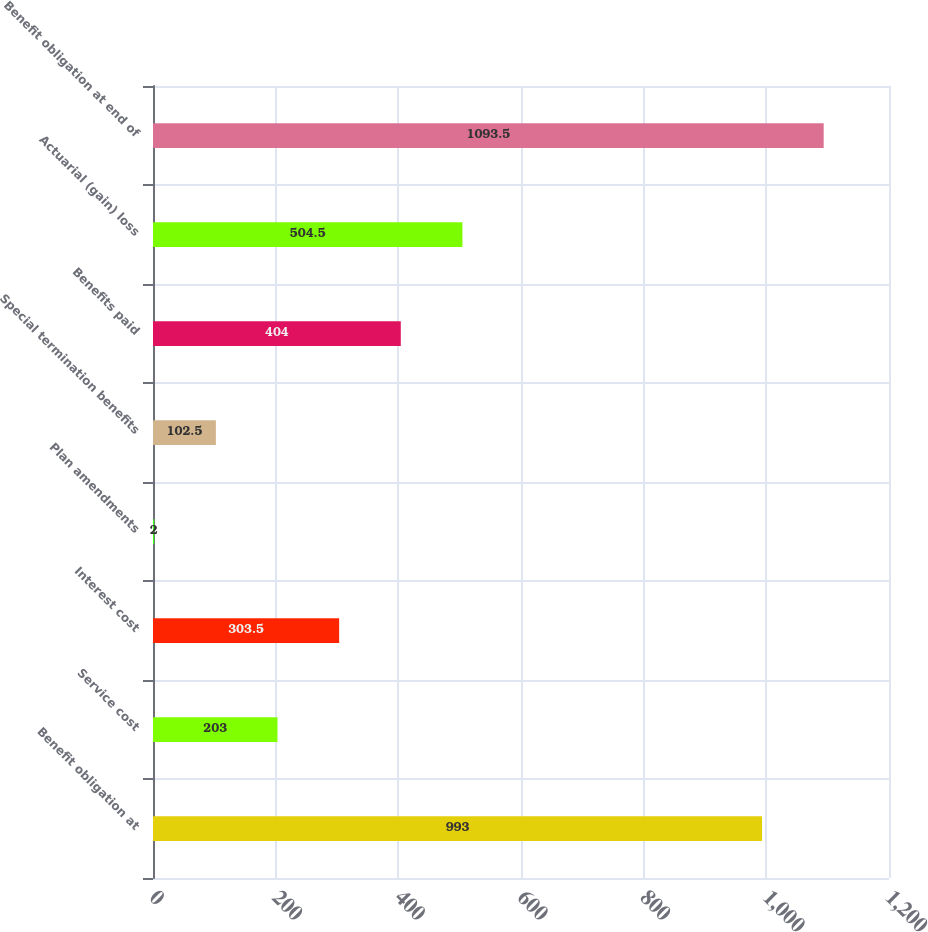Convert chart to OTSL. <chart><loc_0><loc_0><loc_500><loc_500><bar_chart><fcel>Benefit obligation at<fcel>Service cost<fcel>Interest cost<fcel>Plan amendments<fcel>Special termination benefits<fcel>Benefits paid<fcel>Actuarial (gain) loss<fcel>Benefit obligation at end of<nl><fcel>993<fcel>203<fcel>303.5<fcel>2<fcel>102.5<fcel>404<fcel>504.5<fcel>1093.5<nl></chart> 